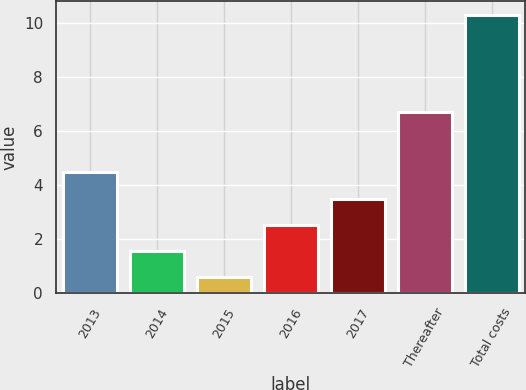Convert chart. <chart><loc_0><loc_0><loc_500><loc_500><bar_chart><fcel>2013<fcel>2014<fcel>2015<fcel>2016<fcel>2017<fcel>Thereafter<fcel>Total costs<nl><fcel>4.48<fcel>1.57<fcel>0.6<fcel>2.54<fcel>3.51<fcel>6.7<fcel>10.3<nl></chart> 